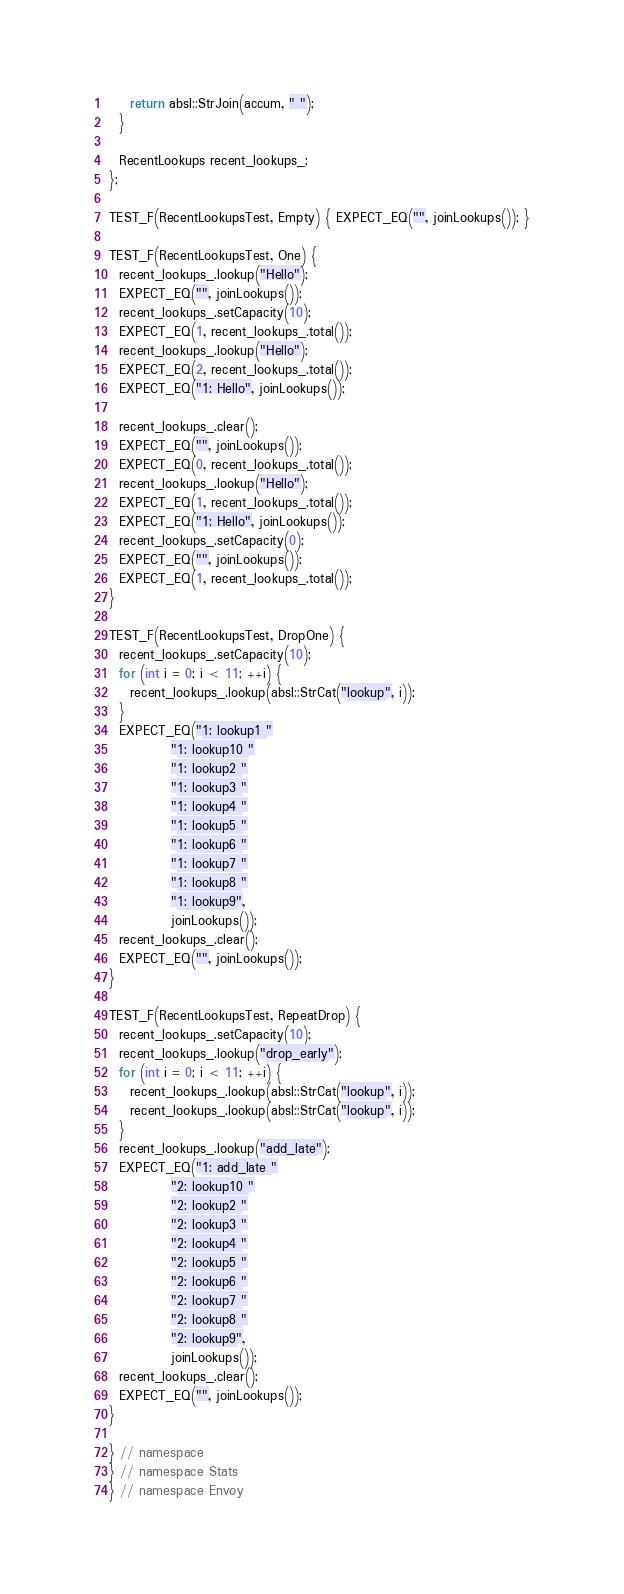<code> <loc_0><loc_0><loc_500><loc_500><_C++_>    return absl::StrJoin(accum, " ");
  }

  RecentLookups recent_lookups_;
};

TEST_F(RecentLookupsTest, Empty) { EXPECT_EQ("", joinLookups()); }

TEST_F(RecentLookupsTest, One) {
  recent_lookups_.lookup("Hello");
  EXPECT_EQ("", joinLookups());
  recent_lookups_.setCapacity(10);
  EXPECT_EQ(1, recent_lookups_.total());
  recent_lookups_.lookup("Hello");
  EXPECT_EQ(2, recent_lookups_.total());
  EXPECT_EQ("1: Hello", joinLookups());

  recent_lookups_.clear();
  EXPECT_EQ("", joinLookups());
  EXPECT_EQ(0, recent_lookups_.total());
  recent_lookups_.lookup("Hello");
  EXPECT_EQ(1, recent_lookups_.total());
  EXPECT_EQ("1: Hello", joinLookups());
  recent_lookups_.setCapacity(0);
  EXPECT_EQ("", joinLookups());
  EXPECT_EQ(1, recent_lookups_.total());
}

TEST_F(RecentLookupsTest, DropOne) {
  recent_lookups_.setCapacity(10);
  for (int i = 0; i < 11; ++i) {
    recent_lookups_.lookup(absl::StrCat("lookup", i));
  }
  EXPECT_EQ("1: lookup1 "
            "1: lookup10 "
            "1: lookup2 "
            "1: lookup3 "
            "1: lookup4 "
            "1: lookup5 "
            "1: lookup6 "
            "1: lookup7 "
            "1: lookup8 "
            "1: lookup9",
            joinLookups());
  recent_lookups_.clear();
  EXPECT_EQ("", joinLookups());
}

TEST_F(RecentLookupsTest, RepeatDrop) {
  recent_lookups_.setCapacity(10);
  recent_lookups_.lookup("drop_early");
  for (int i = 0; i < 11; ++i) {
    recent_lookups_.lookup(absl::StrCat("lookup", i));
    recent_lookups_.lookup(absl::StrCat("lookup", i));
  }
  recent_lookups_.lookup("add_late");
  EXPECT_EQ("1: add_late "
            "2: lookup10 "
            "2: lookup2 "
            "2: lookup3 "
            "2: lookup4 "
            "2: lookup5 "
            "2: lookup6 "
            "2: lookup7 "
            "2: lookup8 "
            "2: lookup9",
            joinLookups());
  recent_lookups_.clear();
  EXPECT_EQ("", joinLookups());
}

} // namespace
} // namespace Stats
} // namespace Envoy
</code> 